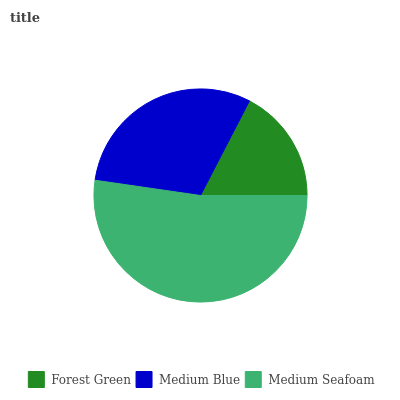Is Forest Green the minimum?
Answer yes or no. Yes. Is Medium Seafoam the maximum?
Answer yes or no. Yes. Is Medium Blue the minimum?
Answer yes or no. No. Is Medium Blue the maximum?
Answer yes or no. No. Is Medium Blue greater than Forest Green?
Answer yes or no. Yes. Is Forest Green less than Medium Blue?
Answer yes or no. Yes. Is Forest Green greater than Medium Blue?
Answer yes or no. No. Is Medium Blue less than Forest Green?
Answer yes or no. No. Is Medium Blue the high median?
Answer yes or no. Yes. Is Medium Blue the low median?
Answer yes or no. Yes. Is Forest Green the high median?
Answer yes or no. No. Is Forest Green the low median?
Answer yes or no. No. 